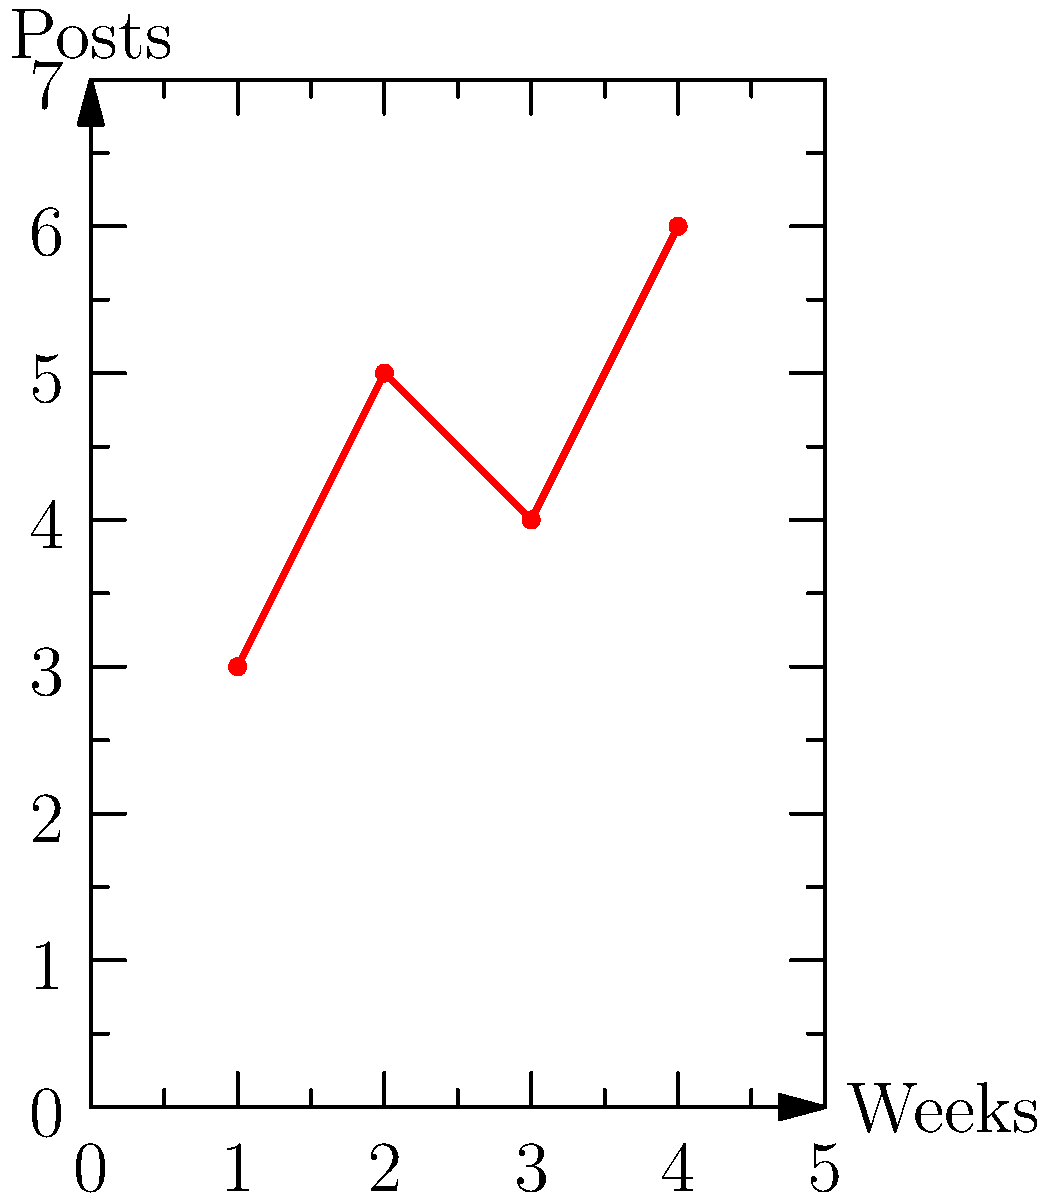Based on the graph showing the number of social media posts per week for an art collective, what is the recommended number of visual post templates needed for a month-long content calendar to maintain variety and consistency? To determine the recommended number of visual post templates for a month-long content calendar, let's follow these steps:

1. Analyze the data:
   - Week 1: 3 posts
   - Week 2: 5 posts
   - Week 3: 4 posts
   - Week 4: 6 posts

2. Calculate the total number of posts for the month:
   $3 + 5 + 4 + 6 = 18$ posts

3. Consider variety:
   To maintain variety, it's recommended to have more templates than the average number of weekly posts. The average is:
   $\frac{18 \text{ posts}}{4 \text{ weeks}} = 4.5$ posts per week

4. Factor in consistency:
   To ensure consistency, create a set of templates that can be rotated throughout the month without exact repetition.

5. Determine the ideal number:
   A good rule of thumb is to have 1.5 to 2 times the average weekly posts. This gives us a range of:
   $4.5 \times 1.5 = 6.75$ to $4.5 \times 2 = 9$ templates

6. Round to a practical number:
   Since we can't have partial templates, we'll round up to the nearest whole number for maximum variety.

Therefore, the recommended number of visual post templates for a month-long content calendar is 9.
Answer: 9 templates 